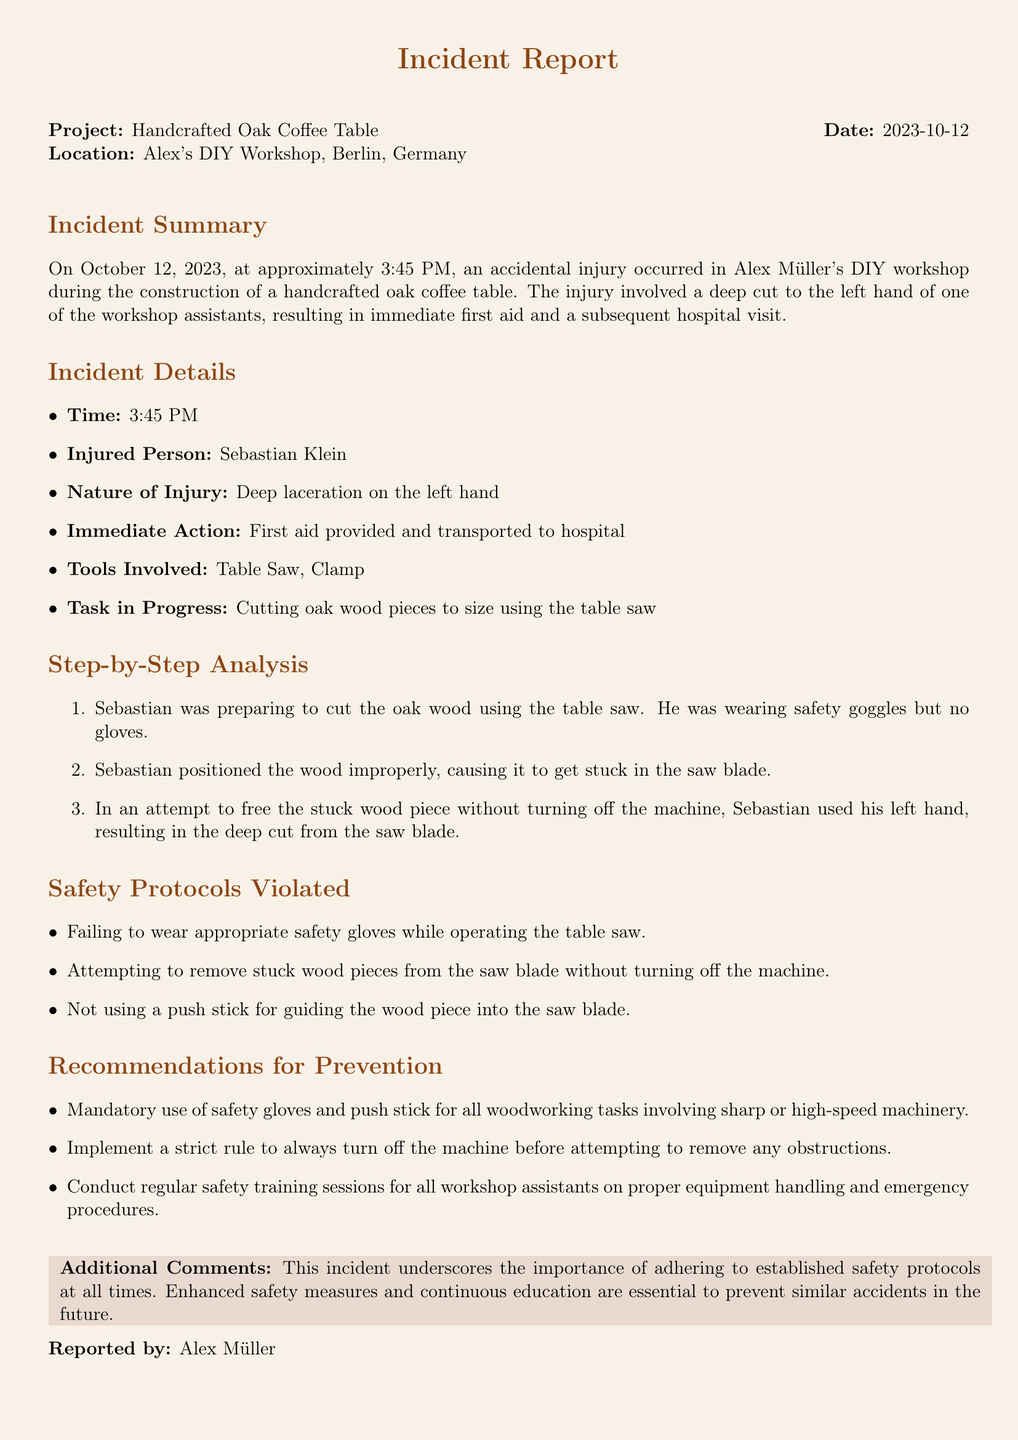What was the date of the incident? The date of the incident is specified in the document, which is October 12, 2023.
Answer: October 12, 2023 Who was injured during the woodworking project? The document identifies the injured person as Sebastian Klein.
Answer: Sebastian Klein What type of injury did Sebastian sustain? The type of injury is detailed in the incident summary, which states it was a deep laceration on the left hand.
Answer: Deep laceration on the left hand What tool was primarily involved in the incident? The tool involved is mentioned as a table saw in the incident details.
Answer: Table Saw What safety protocol was violated regarding machine operation? The document lists several violated protocols, specifically that the machine should be turned off before removing obstructions.
Answer: Turn off the machine How many recommendations are given for future prevention? The section on recommendations lists a total of three measures for future prevention.
Answer: Three Was Sebastian wearing gloves when the incident occurred? The analysis states Sebastian was wearing safety goggles but no gloves at the time of the incident.
Answer: No What immediate action was taken after the injury? The incident document mentions that first aid was provided and Sebastian was transported to the hospital.
Answer: First aid provided and transported to hospital What is the main purpose of this incident report? The purpose of the report is to document the incident and analyze safety violations and recommendations for improvement.
Answer: Document the incident and analyze safety violations 